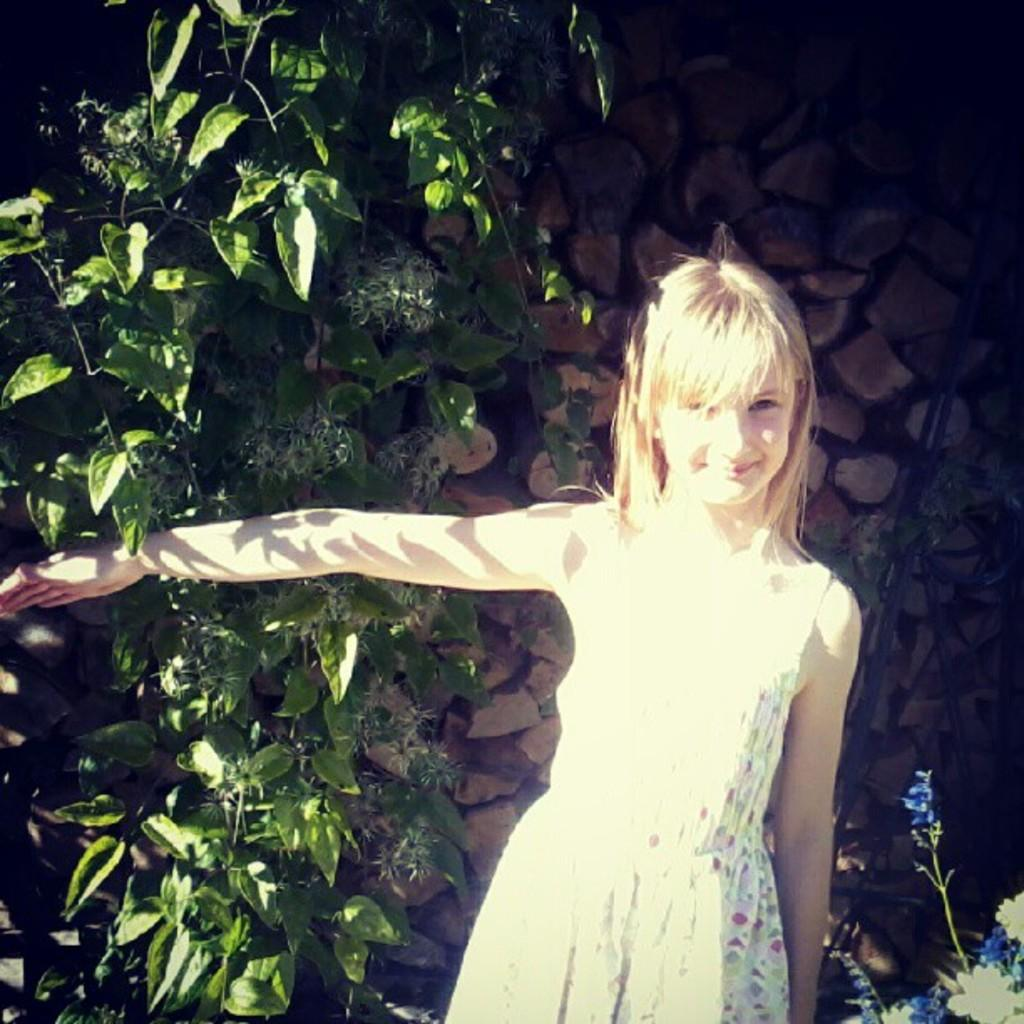Who is the main subject in the image? There is a girl in the image. What is the girl standing in front of? The girl is standing in front of a stone wall. Are there any other elements near the stone wall? Yes, there are plants near the stone wall. What type of ring is the girl wearing on her finger in the image? There is no ring visible on the girl's finger in the image. Is there a lawyer present in the image? There is no mention of a lawyer in the image or the provided facts. 